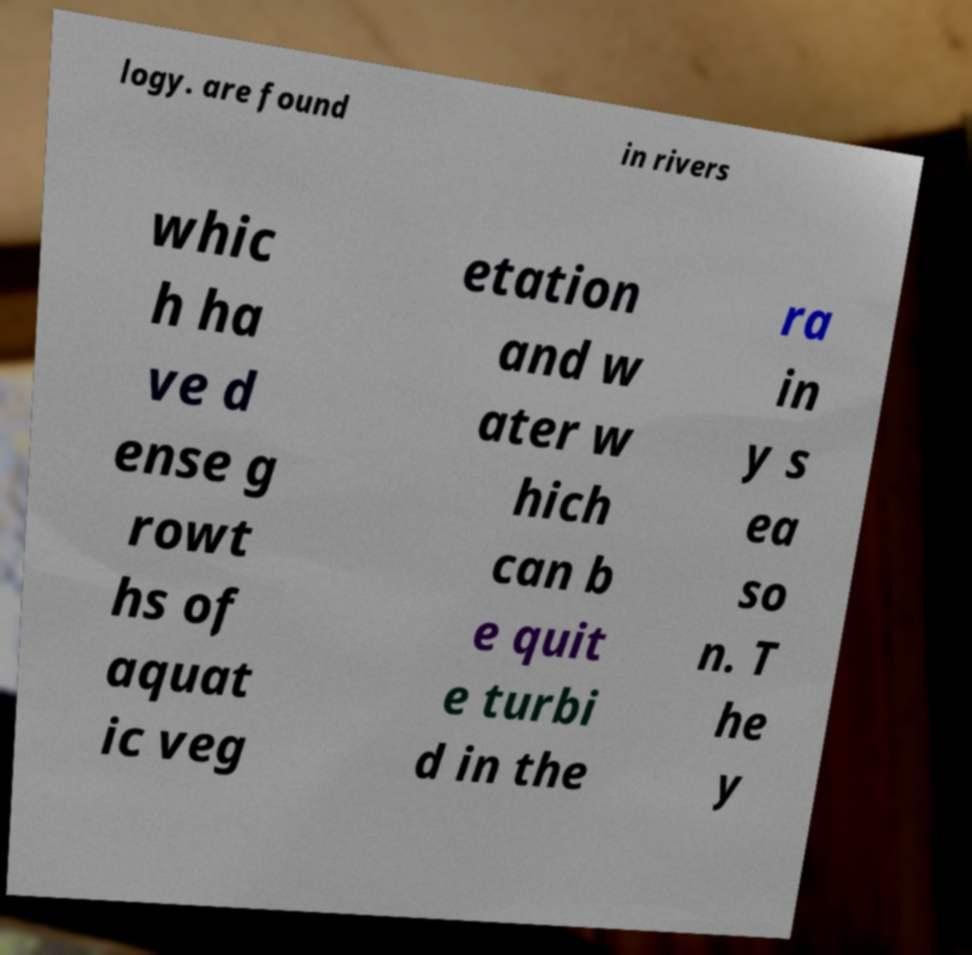There's text embedded in this image that I need extracted. Can you transcribe it verbatim? logy. are found in rivers whic h ha ve d ense g rowt hs of aquat ic veg etation and w ater w hich can b e quit e turbi d in the ra in y s ea so n. T he y 